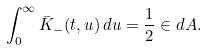<formula> <loc_0><loc_0><loc_500><loc_500>\int _ { 0 } ^ { \infty } \bar { K } _ { - } ( t , u ) \, d u = \frac { 1 } { 2 } \in d A .</formula> 